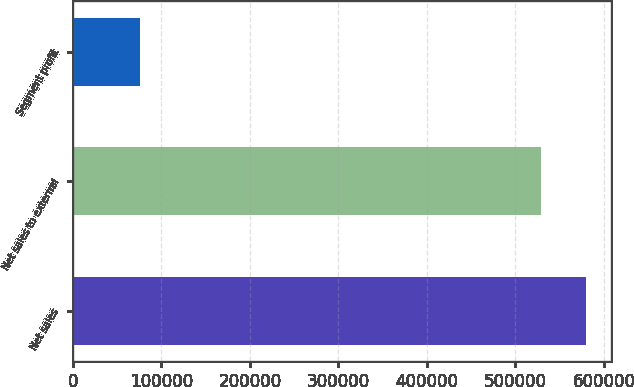Convert chart to OTSL. <chart><loc_0><loc_0><loc_500><loc_500><bar_chart><fcel>Net sales<fcel>Net sales to external<fcel>Segment profit<nl><fcel>579300<fcel>529020<fcel>75651<nl></chart> 